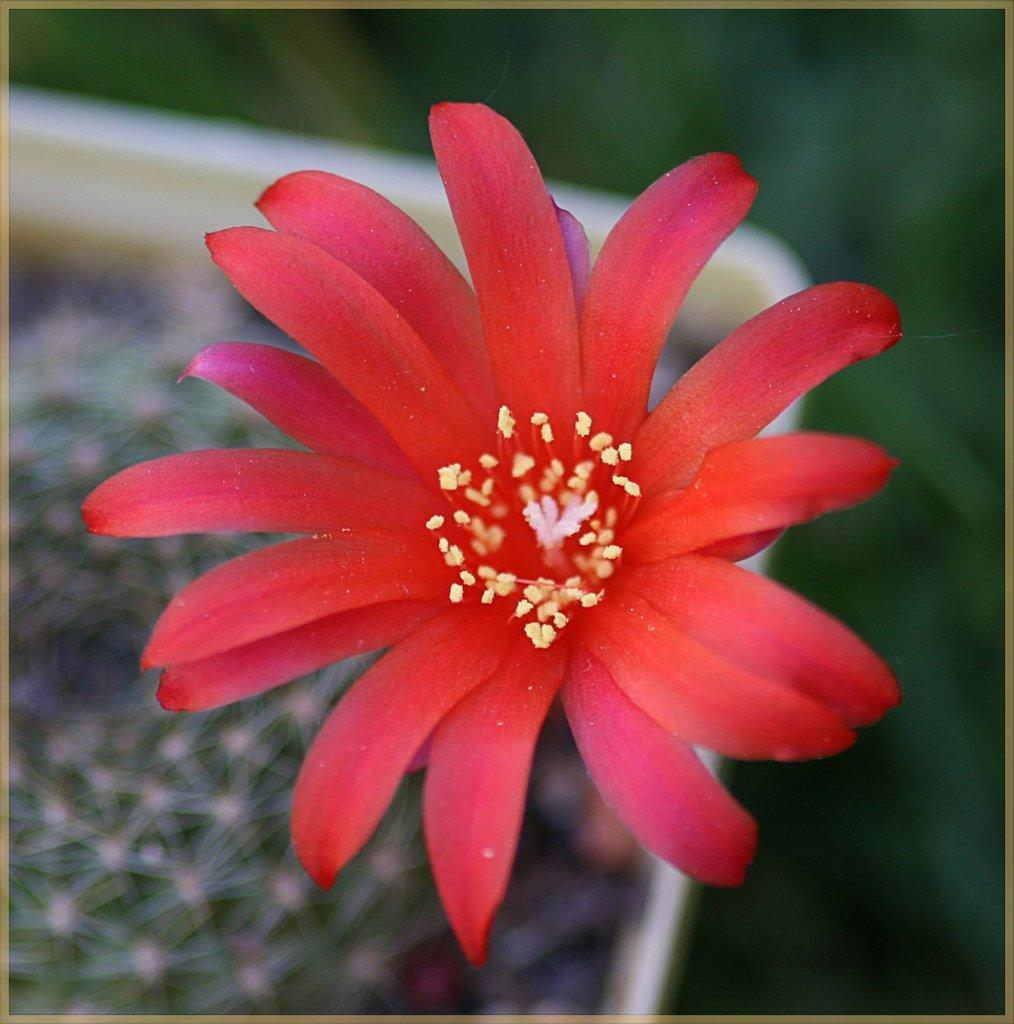Please provide a concise description of this image. In this image we can see a flower which is of red and yellow color and in the background image is blur. 